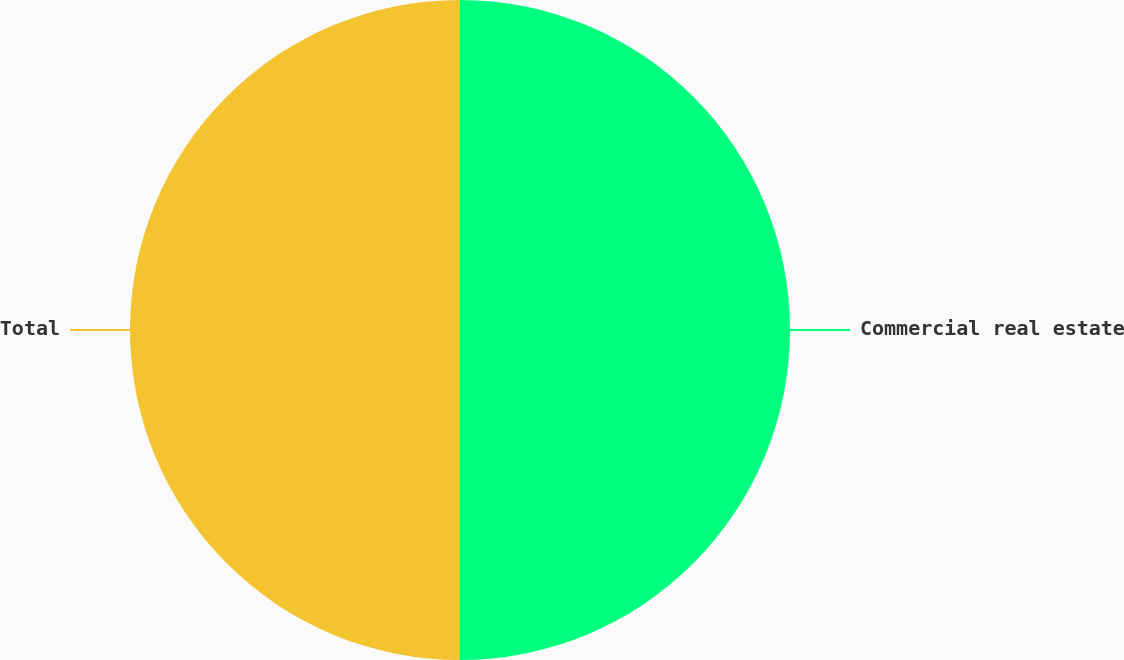Convert chart to OTSL. <chart><loc_0><loc_0><loc_500><loc_500><pie_chart><fcel>Commercial real estate<fcel>Total<nl><fcel>50.0%<fcel>50.0%<nl></chart> 